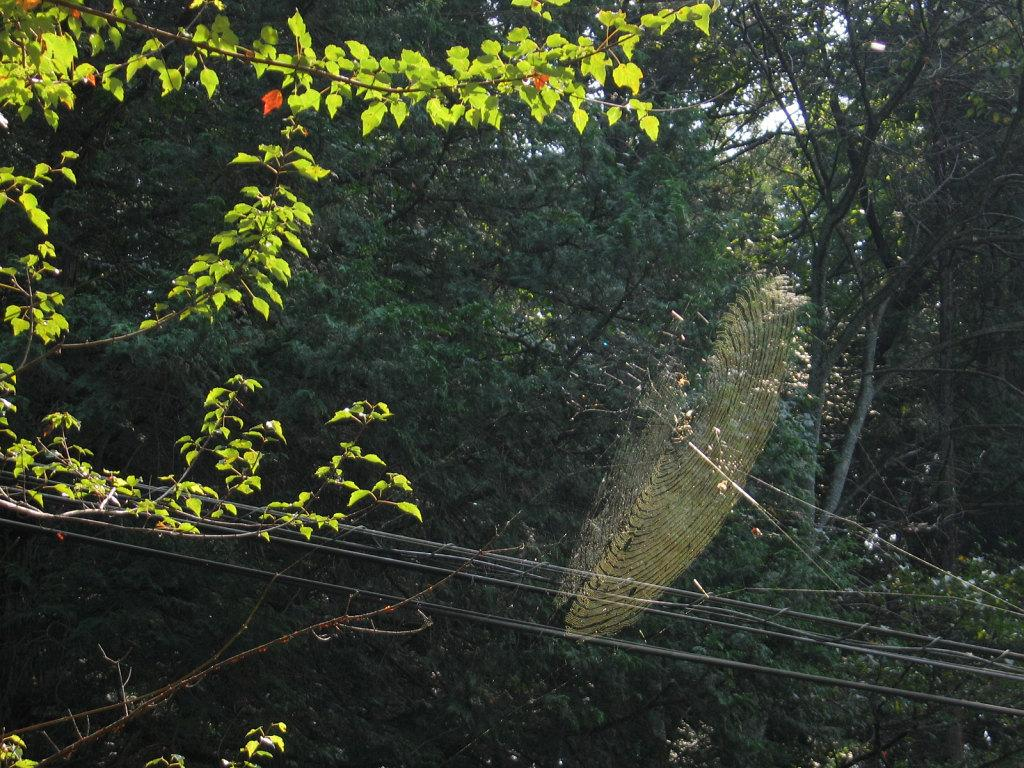What is the main subject of the image? The main subject of the image is a web. What else can be seen in the image besides the web? There are wires and trees visible in the image. What is visible in the background of the image? The sky is visible in the image. What type of birthday cake is being served in the image? There is no birthday cake or any reference to a birthday celebration in the image. 